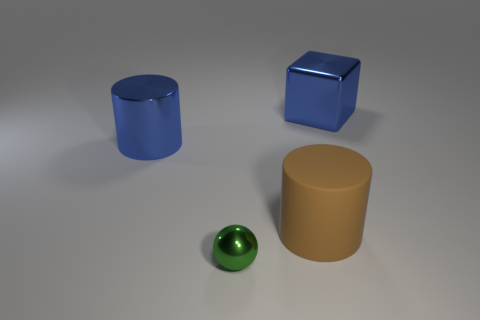Add 4 big gray things. How many objects exist? 8 Subtract all blocks. How many objects are left? 3 Subtract 1 blue cylinders. How many objects are left? 3 Subtract all green metallic balls. Subtract all rubber cylinders. How many objects are left? 2 Add 1 blue metallic cylinders. How many blue metallic cylinders are left? 2 Add 4 small gray things. How many small gray things exist? 4 